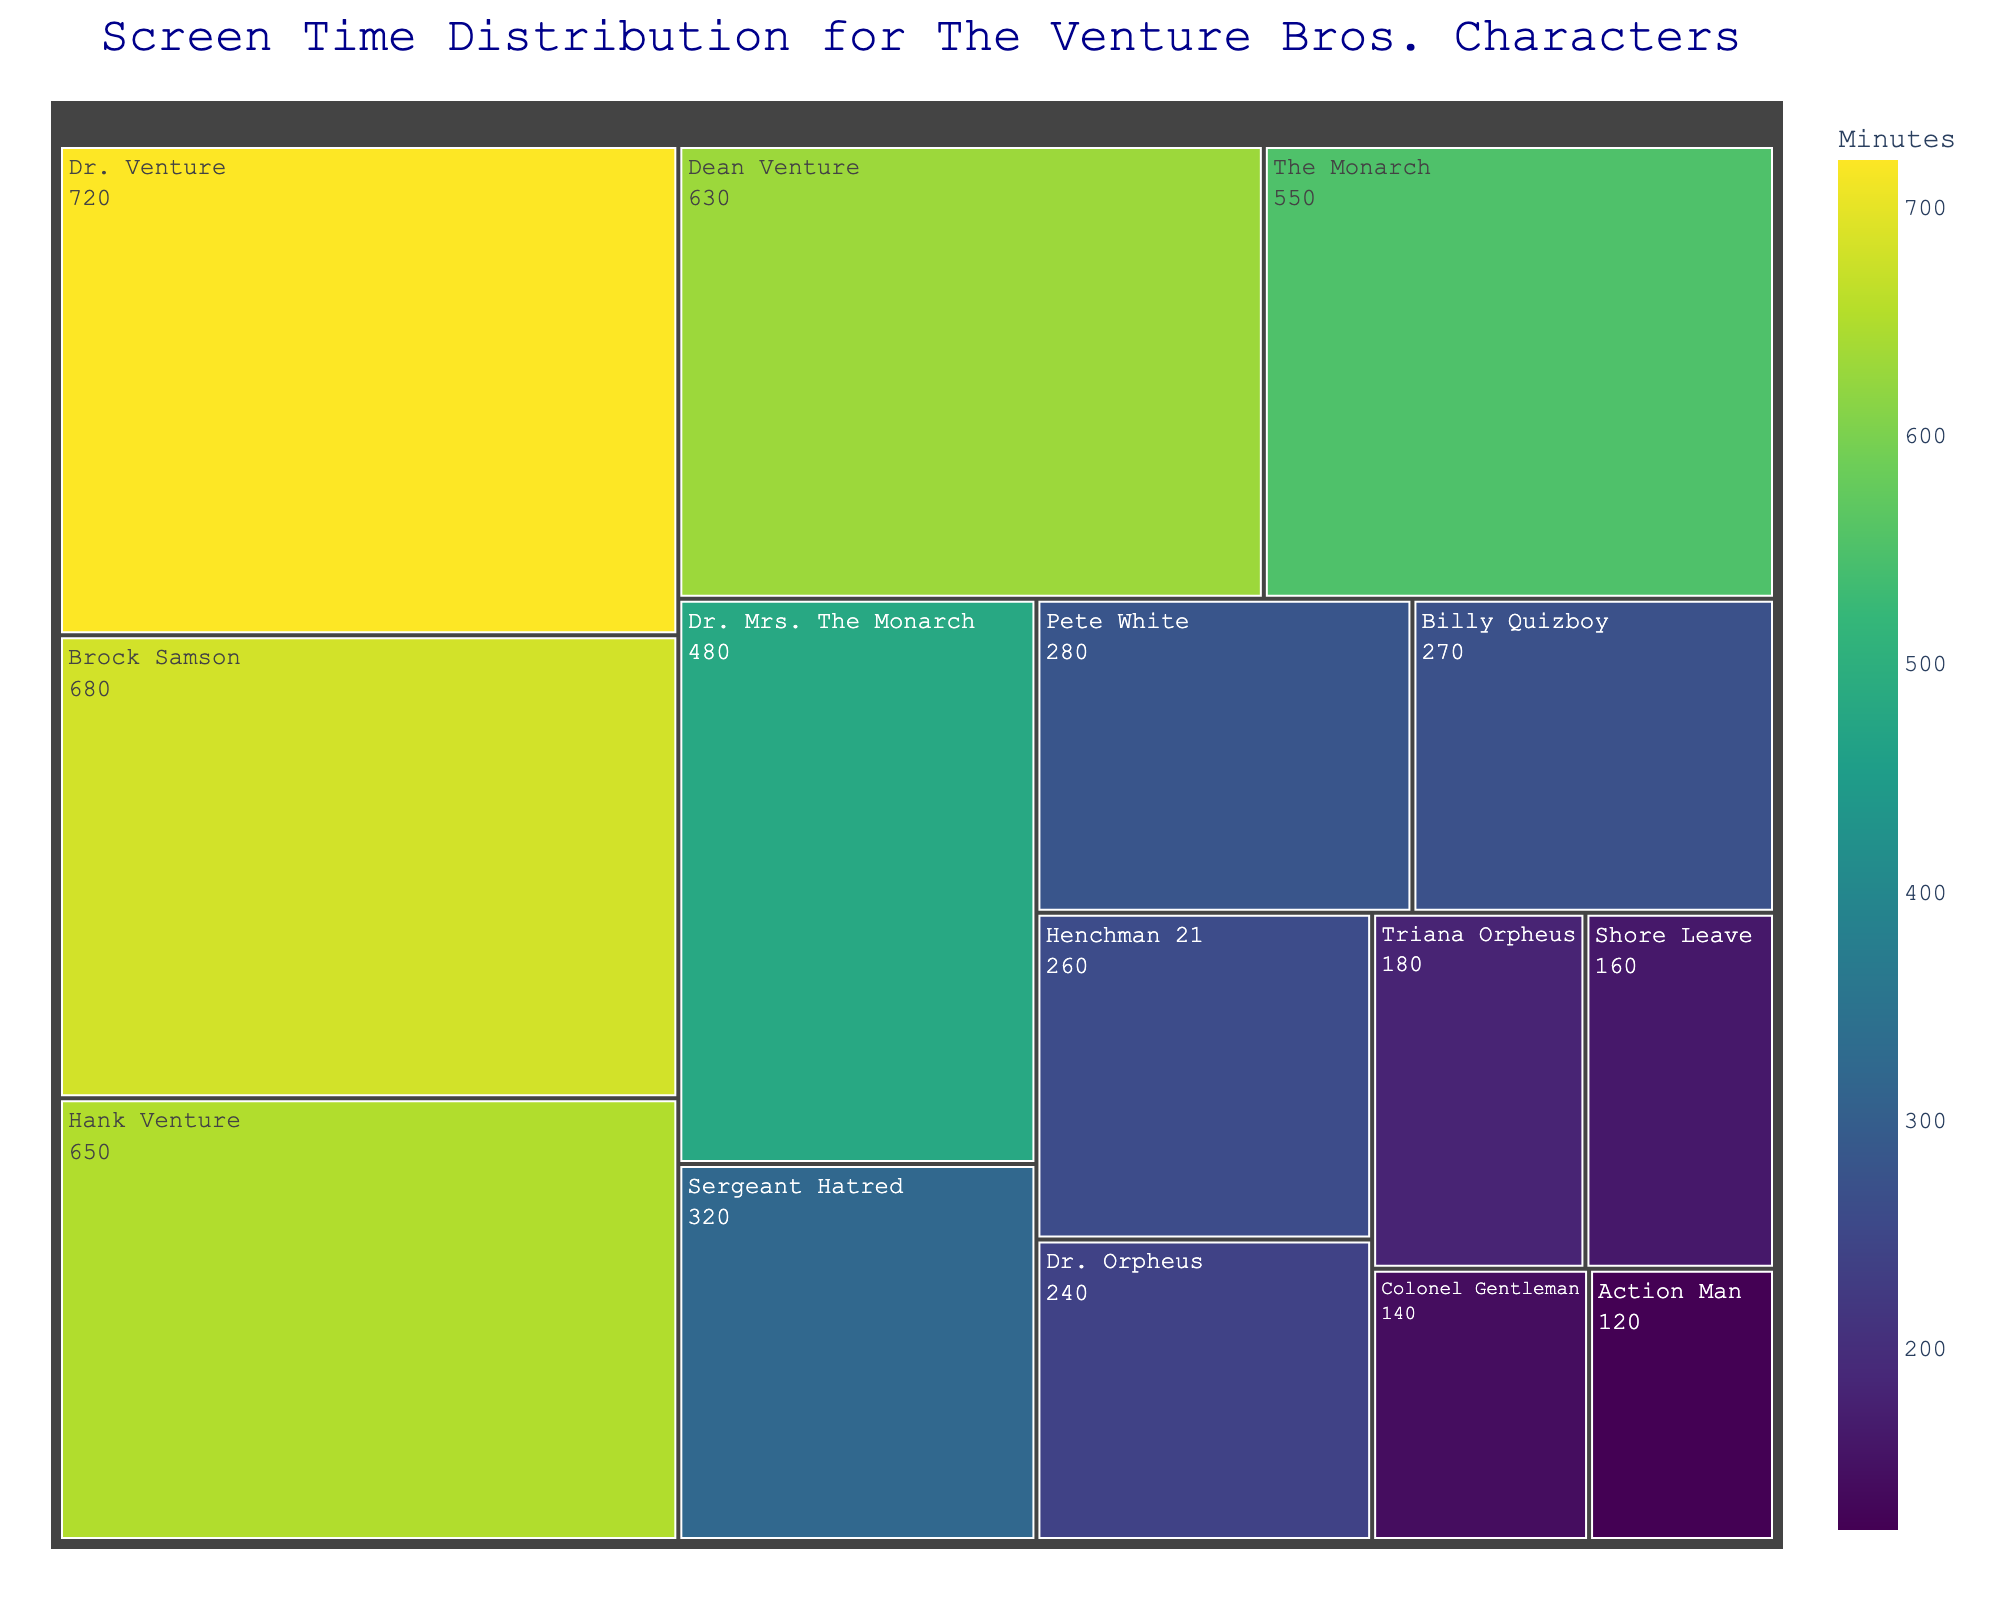How much screen time does Dr. Venture have? Dr. Venture's screen time is labeled directly in the treemap as 720 minutes.
Answer: 720 minutes Which character has the least screen time? By comparing all sections in the treemap, Action Man has the smallest area, indicating the least screen time of 120 minutes.
Answer: Action Man What is the total screen time for the Venture family (Dr. Venture, Hank Venture, Dean Venture)? Add the screen times for Dr. Venture (720), Hank Venture (650), and Dean Venture (630): 720 + 650 + 630 = 2000 minutes.
Answer: 2000 minutes Who has more screen time, Hank Venture or The Monarch? Compare the screen times of Hank Venture (650) and The Monarch (550), where Hank Venture's screen time is greater.
Answer: Hank Venture How much more screen time does Brock Samson have compared to Dr. Mrs. The Monarch? Subtract the screen time of Dr. Mrs. The Monarch (480) from Brock Samson (680): 680 - 480 = 200 minutes.
Answer: 200 minutes Arrange the characters by screen time in descending order. The characters are ordered in this way from the treemap data: Dr. Venture (720), Brock Samson (680), Hank Venture (650), Dean Venture (630), The Monarch (550), Dr. Mrs. The Monarch (480), Sergeant Hatred (320), Pete White (280), Billy Quizboy (270), Henchman 21 (260), Dr. Orpheus (240), Triana Orpheus (180), Shore Leave (160), Colonel Gentleman (140), Action Man (120).
Answer: Dr. Venture, Brock Samson, Hank Venture, Dean Venture, The Monarch, Dr. Mrs. The Monarch, Sergeant Hatred, Pete White, Billy Quizboy, Henchman 21, Dr. Orpheus, Triana Orpheus, Shore Leave, Colonel Gentleman, Action Man Which characters have a screen time between 200 and 300 minutes? Based on the treemap, Sergeant Hatred (320), Pete White (280), Billy Quizboy (270), and Henchman 21 (260) are within this range.
Answer: Pete White, Billy Quizboy, Henchman 21 What percentage of the total screen time does Dr. Venture represent? Calculate the total screen time of all characters combined and then find the percentage of Dr. Venture's screen time. Sum of all screen times is 720 + 680 + 650 + 630 + 550 + 480 + 320 + 280 + 270 + 260 + 240 + 180 + 160 + 140 + 120 = 5680 minutes. Percentage = (720 / 5680) * 100 = 12.68%.
Answer: 12.68% Who has more screen time, Colonel Gentleman or Dr. Orpheus? Compare the screen times shown in the treemap: Dr. Orpheus (240) and Colonel Gentleman (140). Dr. Orpheus has more screen time.
Answer: Dr. Orpheus 